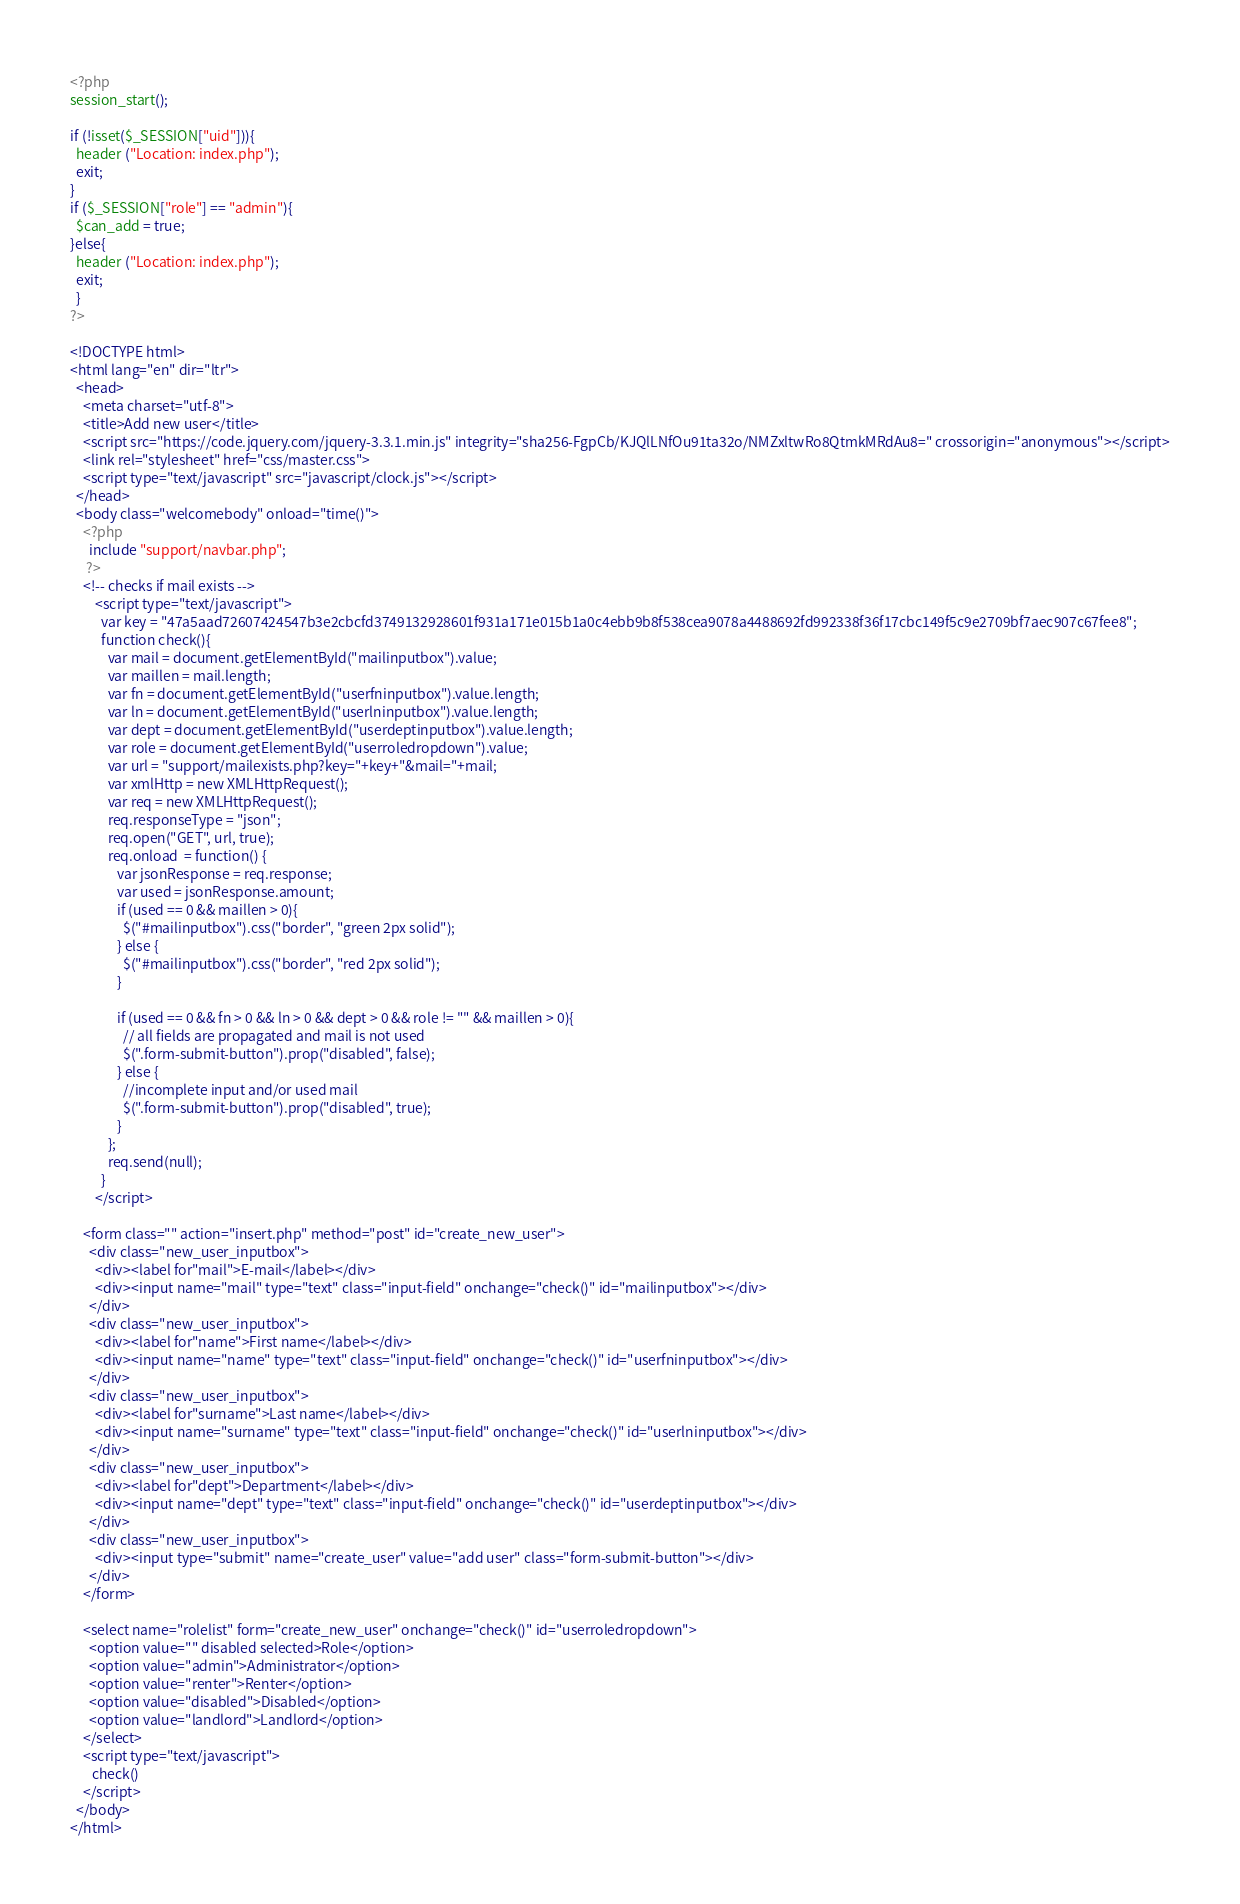Convert code to text. <code><loc_0><loc_0><loc_500><loc_500><_PHP_><?php
session_start();

if (!isset($_SESSION["uid"])){
  header ("Location: index.php");
  exit;
}
if ($_SESSION["role"] == "admin"){
  $can_add = true;
}else{
  header ("Location: index.php");
  exit;
  }
?>

<!DOCTYPE html>
<html lang="en" dir="ltr">
  <head>
    <meta charset="utf-8">
    <title>Add new user</title>
    <script src="https://code.jquery.com/jquery-3.3.1.min.js" integrity="sha256-FgpCb/KJQlLNfOu91ta32o/NMZxltwRo8QtmkMRdAu8=" crossorigin="anonymous"></script>
    <link rel="stylesheet" href="css/master.css">
    <script type="text/javascript" src="javascript/clock.js"></script>
  </head>
  <body class="welcomebody" onload="time()">
    <?php
      include "support/navbar.php";
     ?>
    <!-- checks if mail exists -->
        <script type="text/javascript">
          var key = "47a5aad72607424547b3e2cbcfd3749132928601f931a171e015b1a0c4ebb9b8f538cea9078a4488692fd992338f36f17cbc149f5c9e2709bf7aec907c67fee8";
          function check(){
            var mail = document.getElementById("mailinputbox").value;
            var maillen = mail.length;
            var fn = document.getElementById("userfninputbox").value.length;
            var ln = document.getElementById("userlninputbox").value.length;
            var dept = document.getElementById("userdeptinputbox").value.length;
            var role = document.getElementById("userroledropdown").value;
            var url = "support/mailexists.php?key="+key+"&mail="+mail;
            var xmlHttp = new XMLHttpRequest();
            var req = new XMLHttpRequest();
            req.responseType = "json";
            req.open("GET", url, true);
            req.onload  = function() {
               var jsonResponse = req.response;
               var used = jsonResponse.amount;
               if (used == 0 && maillen > 0){
                 $("#mailinputbox").css("border", "green 2px solid");
               } else {
                 $("#mailinputbox").css("border", "red 2px solid");
               }

               if (used == 0 && fn > 0 && ln > 0 && dept > 0 && role != "" && maillen > 0){
                 // all fields are propagated and mail is not used
                 $(".form-submit-button").prop("disabled", false);
               } else {
                 //incomplete input and/or used mail
                 $(".form-submit-button").prop("disabled", true);
               }
            };
            req.send(null);
          }
        </script>

    <form class="" action="insert.php" method="post" id="create_new_user">
      <div class="new_user_inputbox">
        <div><label for"mail">E-mail</label></div>
        <div><input name="mail" type="text" class="input-field" onchange="check()" id="mailinputbox"></div>
      </div>
      <div class="new_user_inputbox">
        <div><label for"name">First name</label></div>
        <div><input name="name" type="text" class="input-field" onchange="check()" id="userfninputbox"></div>
      </div>
      <div class="new_user_inputbox">
        <div><label for"surname">Last name</label></div>
        <div><input name="surname" type="text" class="input-field" onchange="check()" id="userlninputbox"></div>
      </div>
      <div class="new_user_inputbox">
        <div><label for"dept">Department</label></div>
        <div><input name="dept" type="text" class="input-field" onchange="check()" id="userdeptinputbox"></div>
      </div>
      <div class="new_user_inputbox">
        <div><input type="submit" name="create_user" value="add user" class="form-submit-button"></div>
      </div>
    </form>

    <select name="rolelist" form="create_new_user" onchange="check()" id="userroledropdown">
      <option value="" disabled selected>Role</option>
      <option value="admin">Administrator</option>
      <option value="renter">Renter</option>
      <option value="disabled">Disabled</option>
      <option value="landlord">Landlord</option>
    </select>
    <script type="text/javascript">
       check()
    </script>
  </body>
</html>
</code> 